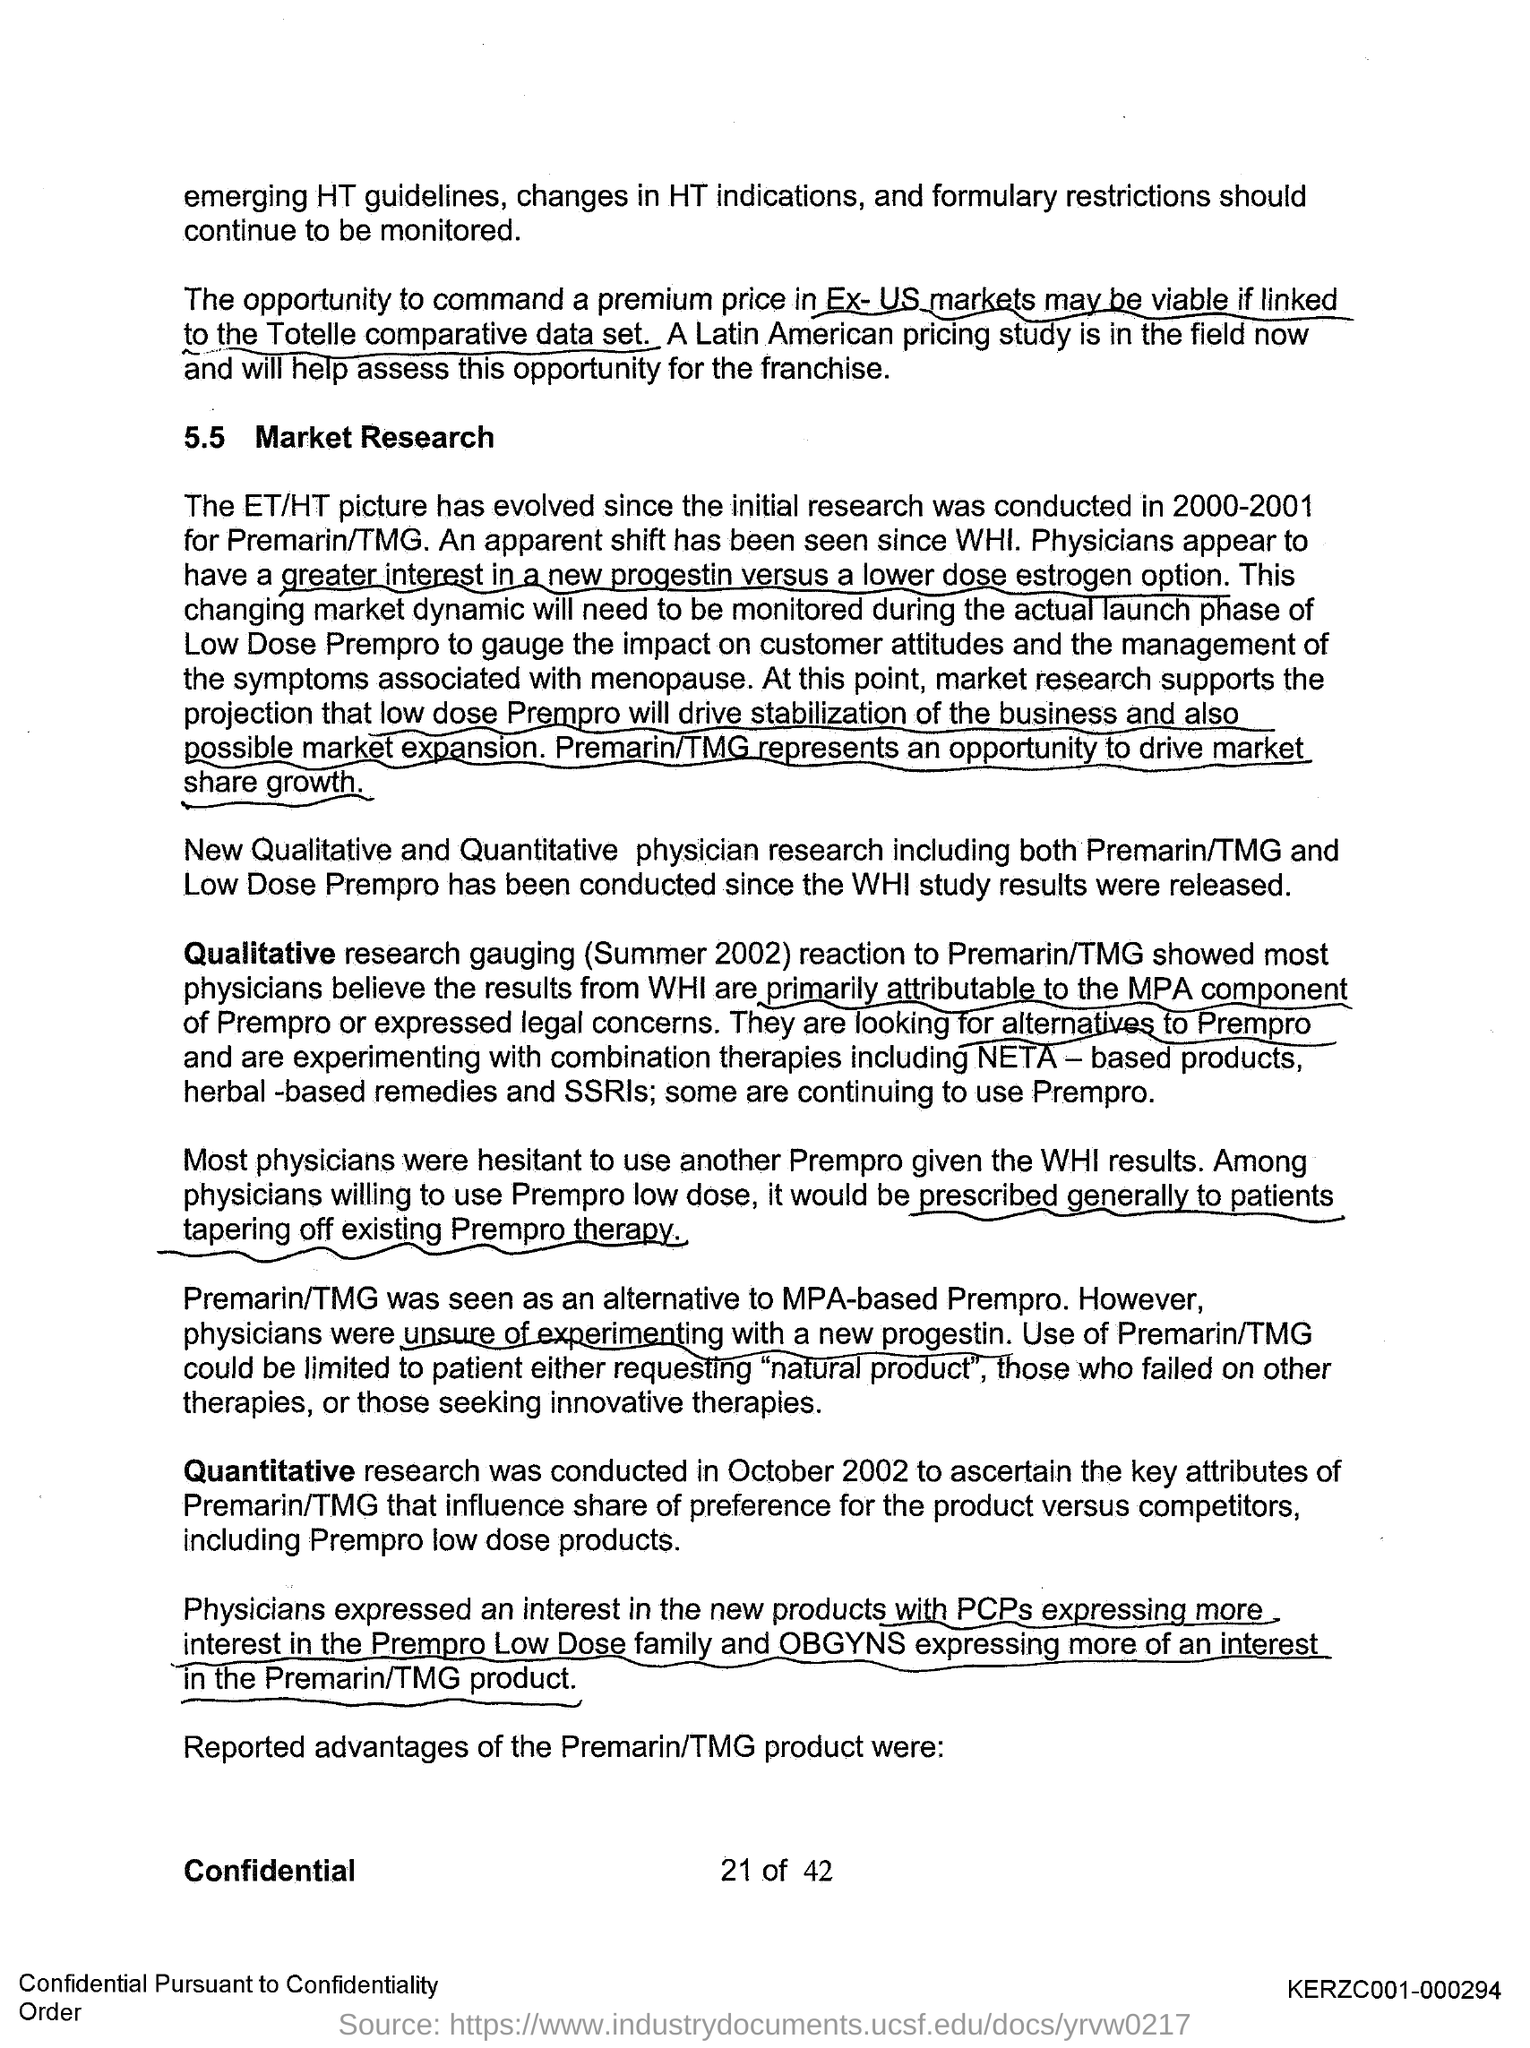What is the first title in the document?
Your answer should be compact. Market Research. 